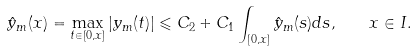Convert formula to latex. <formula><loc_0><loc_0><loc_500><loc_500>\hat { y } _ { m } ( x ) = \max _ { t \in [ 0 , x ] } | y _ { m } ( t ) | \leqslant C _ { 2 } + C _ { 1 } \int _ { [ 0 , x ] } \hat { y } _ { m } ( s ) d s , \quad x \in I .</formula> 